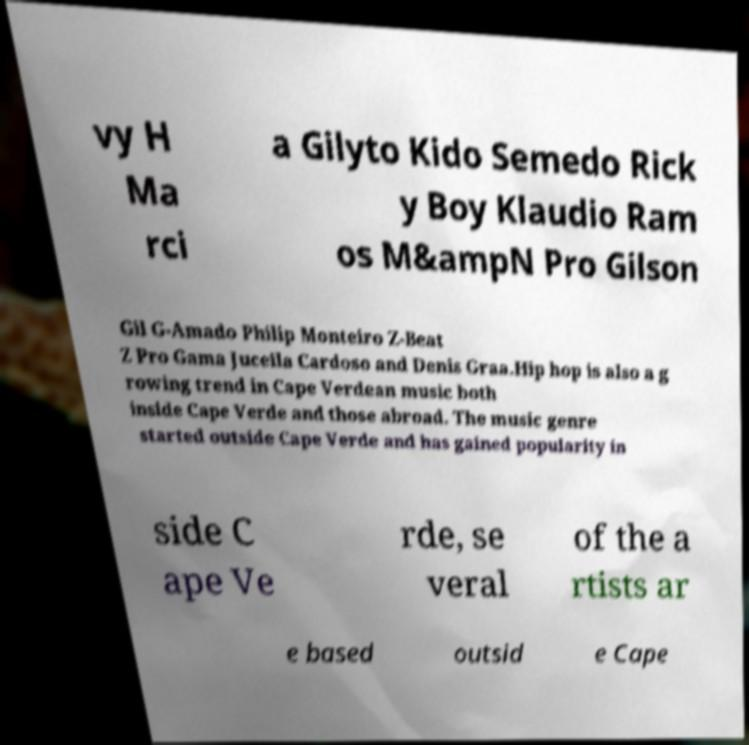For documentation purposes, I need the text within this image transcribed. Could you provide that? vy H Ma rci a Gilyto Kido Semedo Rick y Boy Klaudio Ram os M&ampN Pro Gilson Gil G-Amado Philip Monteiro Z-Beat Z Pro Gama Juceila Cardoso and Denis Graa.Hip hop is also a g rowing trend in Cape Verdean music both inside Cape Verde and those abroad. The music genre started outside Cape Verde and has gained popularity in side C ape Ve rde, se veral of the a rtists ar e based outsid e Cape 